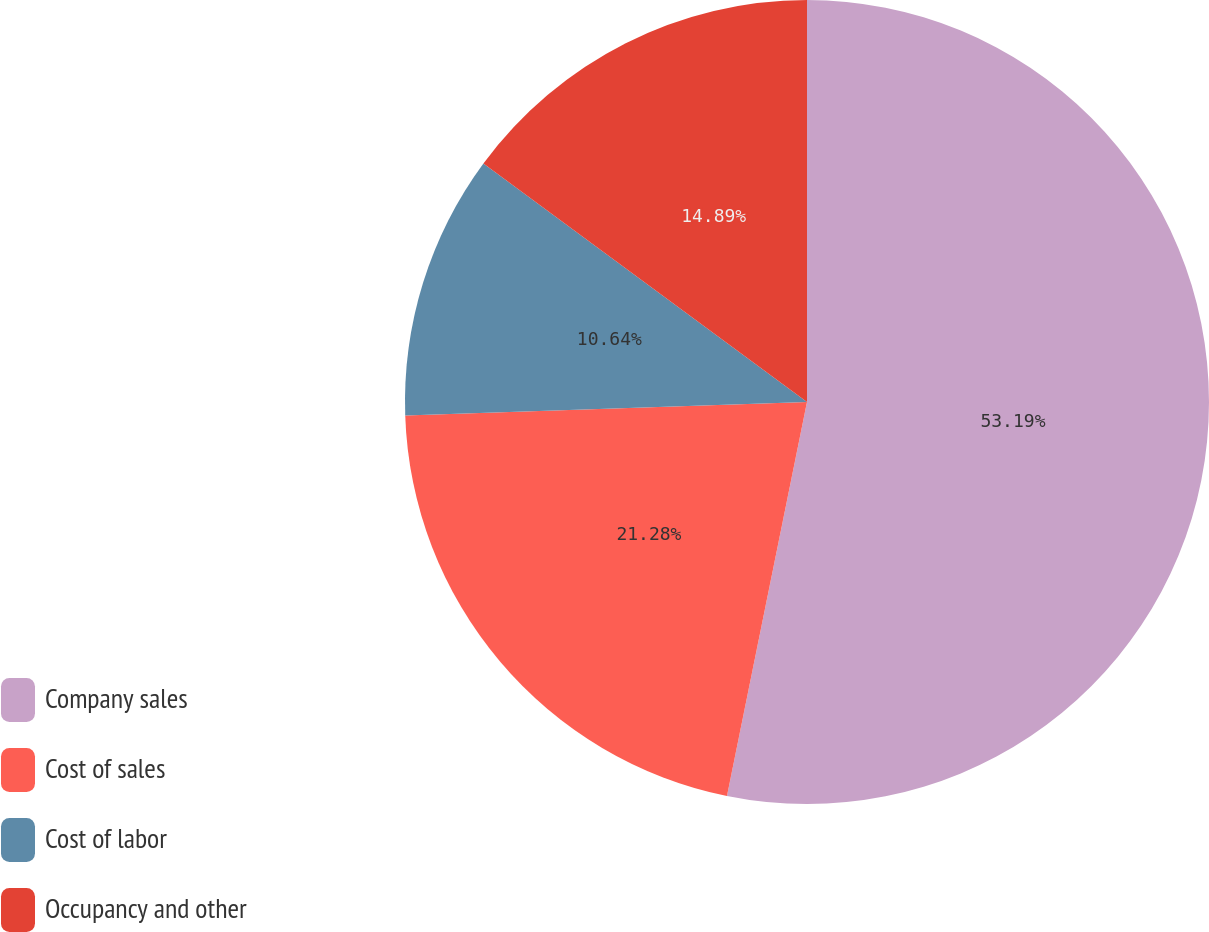Convert chart to OTSL. <chart><loc_0><loc_0><loc_500><loc_500><pie_chart><fcel>Company sales<fcel>Cost of sales<fcel>Cost of labor<fcel>Occupancy and other<nl><fcel>53.19%<fcel>21.28%<fcel>10.64%<fcel>14.89%<nl></chart> 